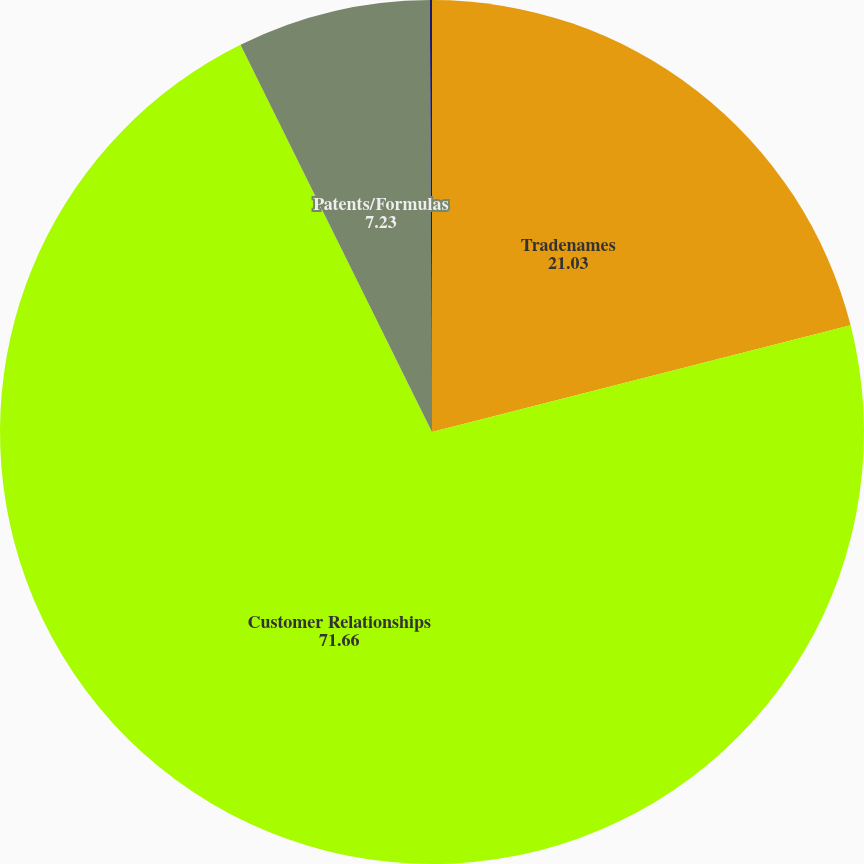Convert chart to OTSL. <chart><loc_0><loc_0><loc_500><loc_500><pie_chart><fcel>Tradenames<fcel>Customer Relationships<fcel>Patents/Formulas<fcel>Non Compete Agreement<nl><fcel>21.03%<fcel>71.66%<fcel>7.23%<fcel>0.08%<nl></chart> 